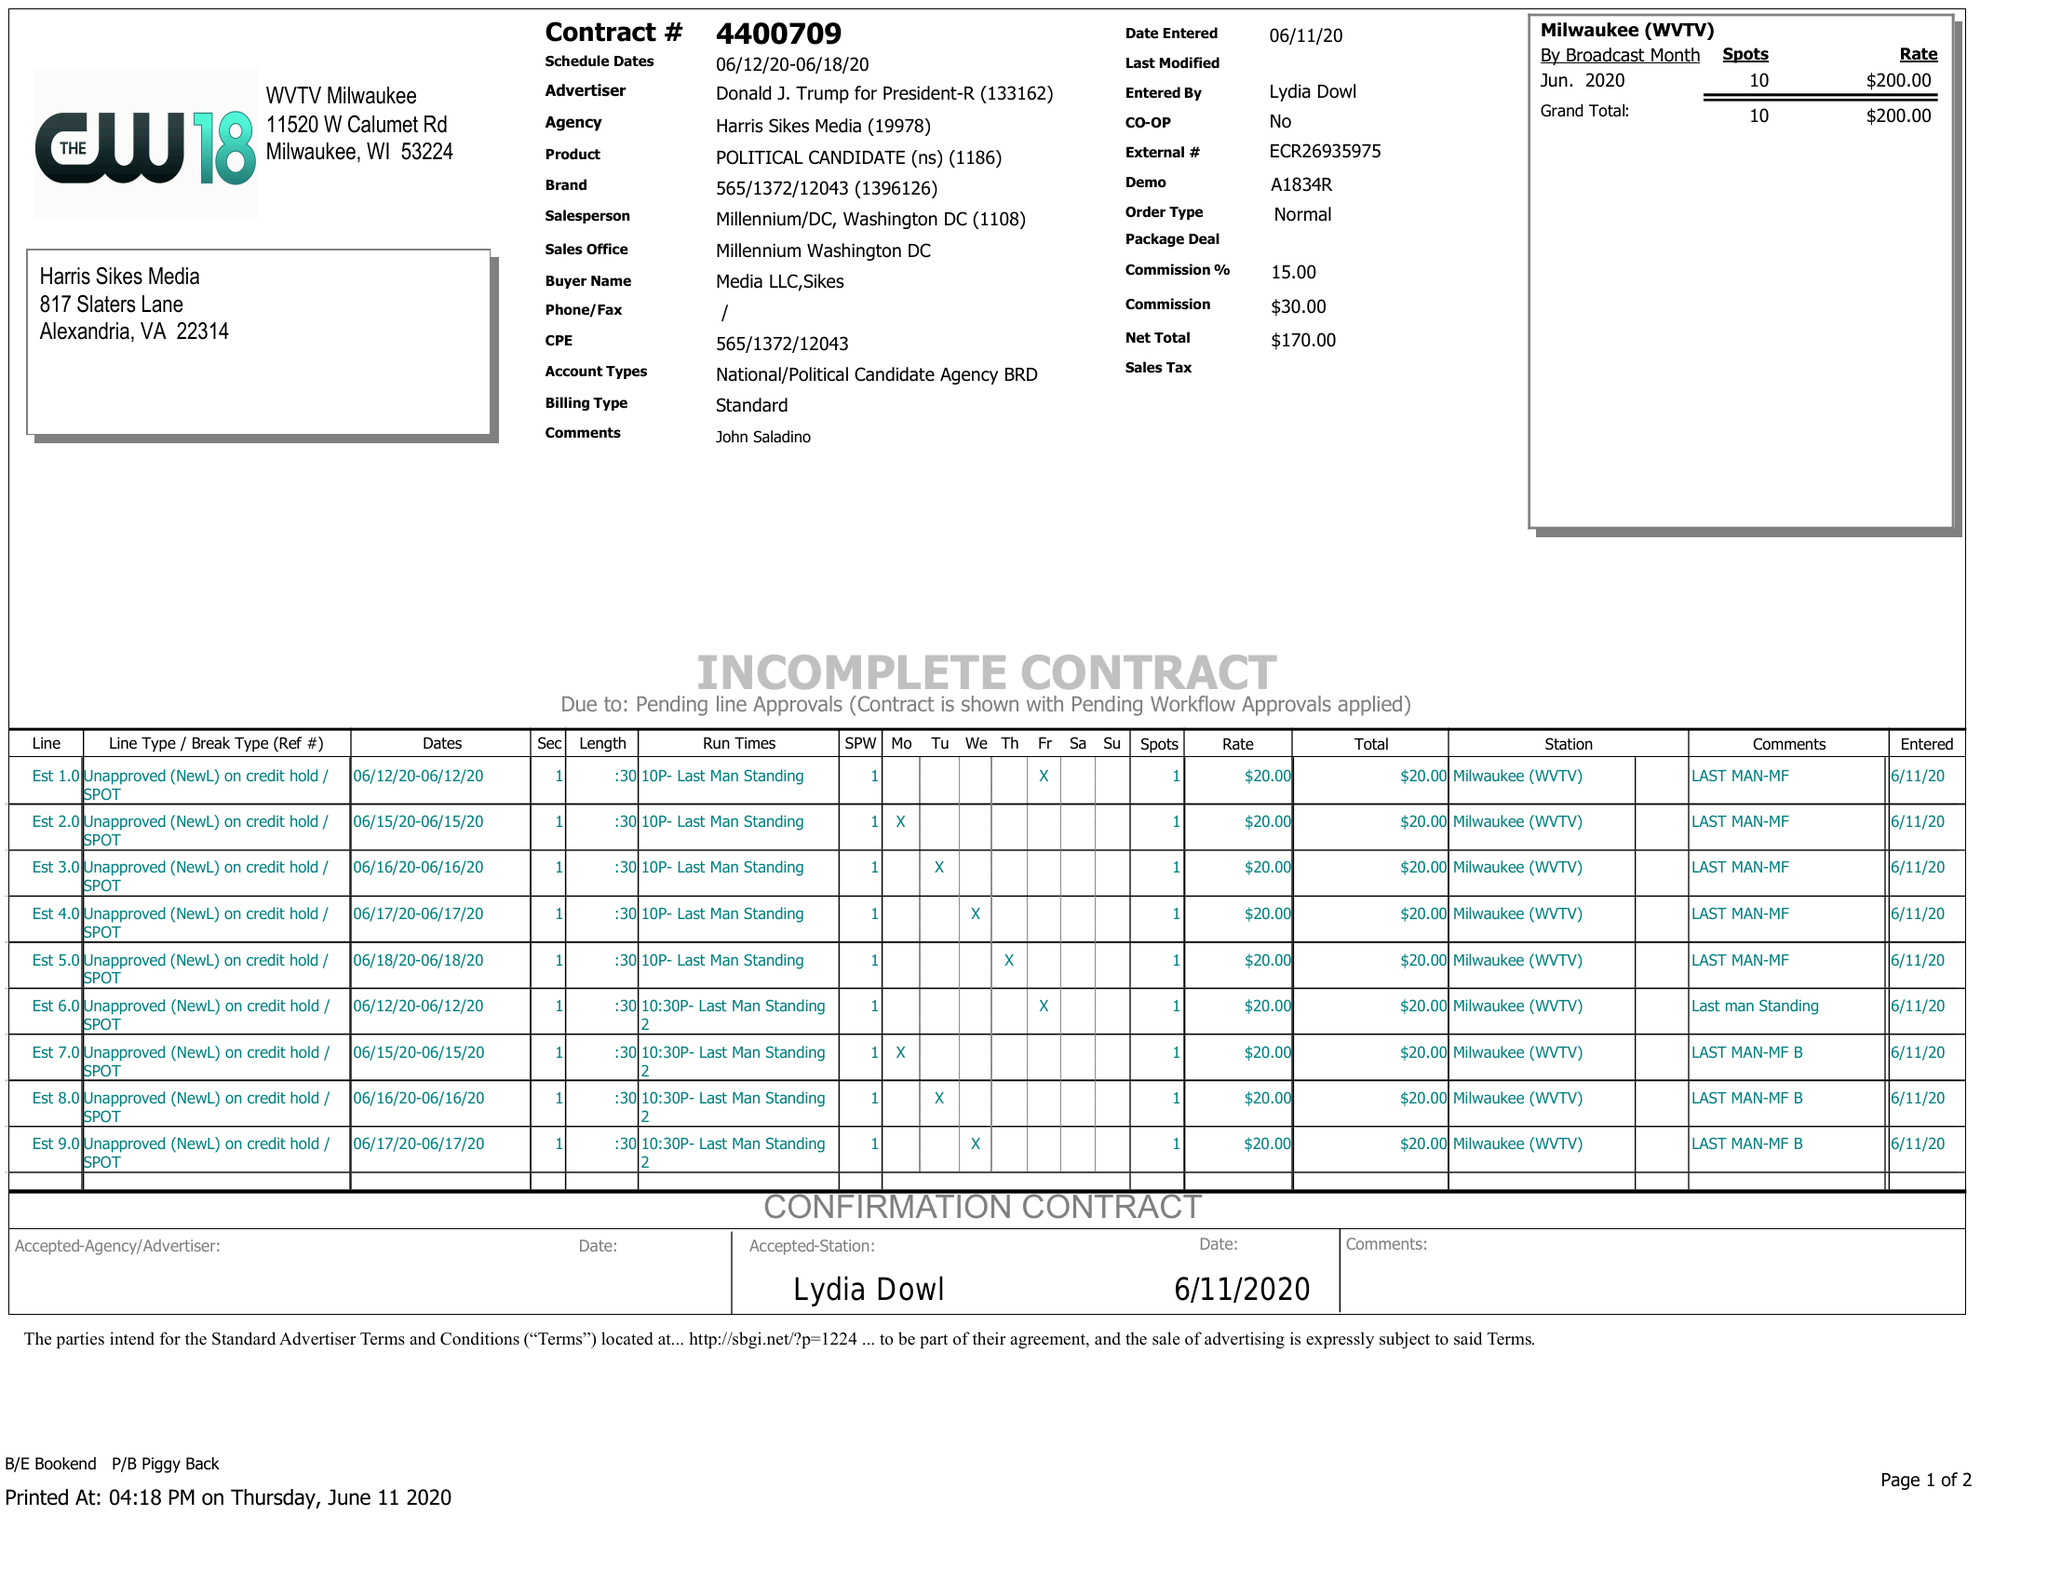What is the value for the flight_to?
Answer the question using a single word or phrase. 06/18/20 